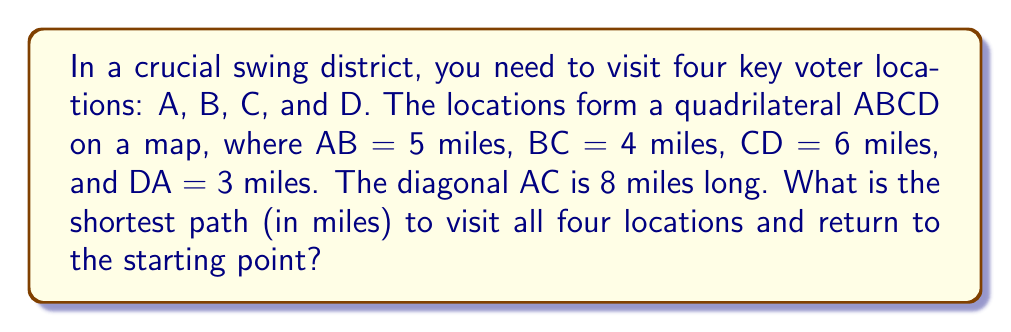Teach me how to tackle this problem. To find the shortest path, we need to determine which route around the quadrilateral is shorter: ABCDA or ADCBA.

Step 1: Calculate the length of ABCDA
$$ABCDA = AB + BC + CD + DA = 5 + 4 + 6 + 3 = 18\text{ miles}$$

Step 2: Calculate the length of ADCBA
$$ADCBA = AD + DC + CB + BA = 3 + 6 + 4 + 5 = 18\text{ miles}$$

Step 3: Compare the two paths
Both paths have the same length of 18 miles.

Step 4: Consider the diagonal AC
The diagonal AC (8 miles) is shorter than the sum of AB + BC (5 + 4 = 9 miles) and the sum of AD + DC (3 + 6 = 9 miles).

Step 5: Determine the shortest path
The shortest path would be to use the diagonal AC twice:
$$A \to C \to B \to A \to D \to C \to A$$

Step 6: Calculate the length of the shortest path
$$AC + CB + BA + AD + DC + CA = 8 + 4 + 5 + 3 + 6 + 8 = 34\text{ miles}$$

This path is shorter than going around the perimeter (18 miles) twice (36 miles).
Answer: 34 miles 